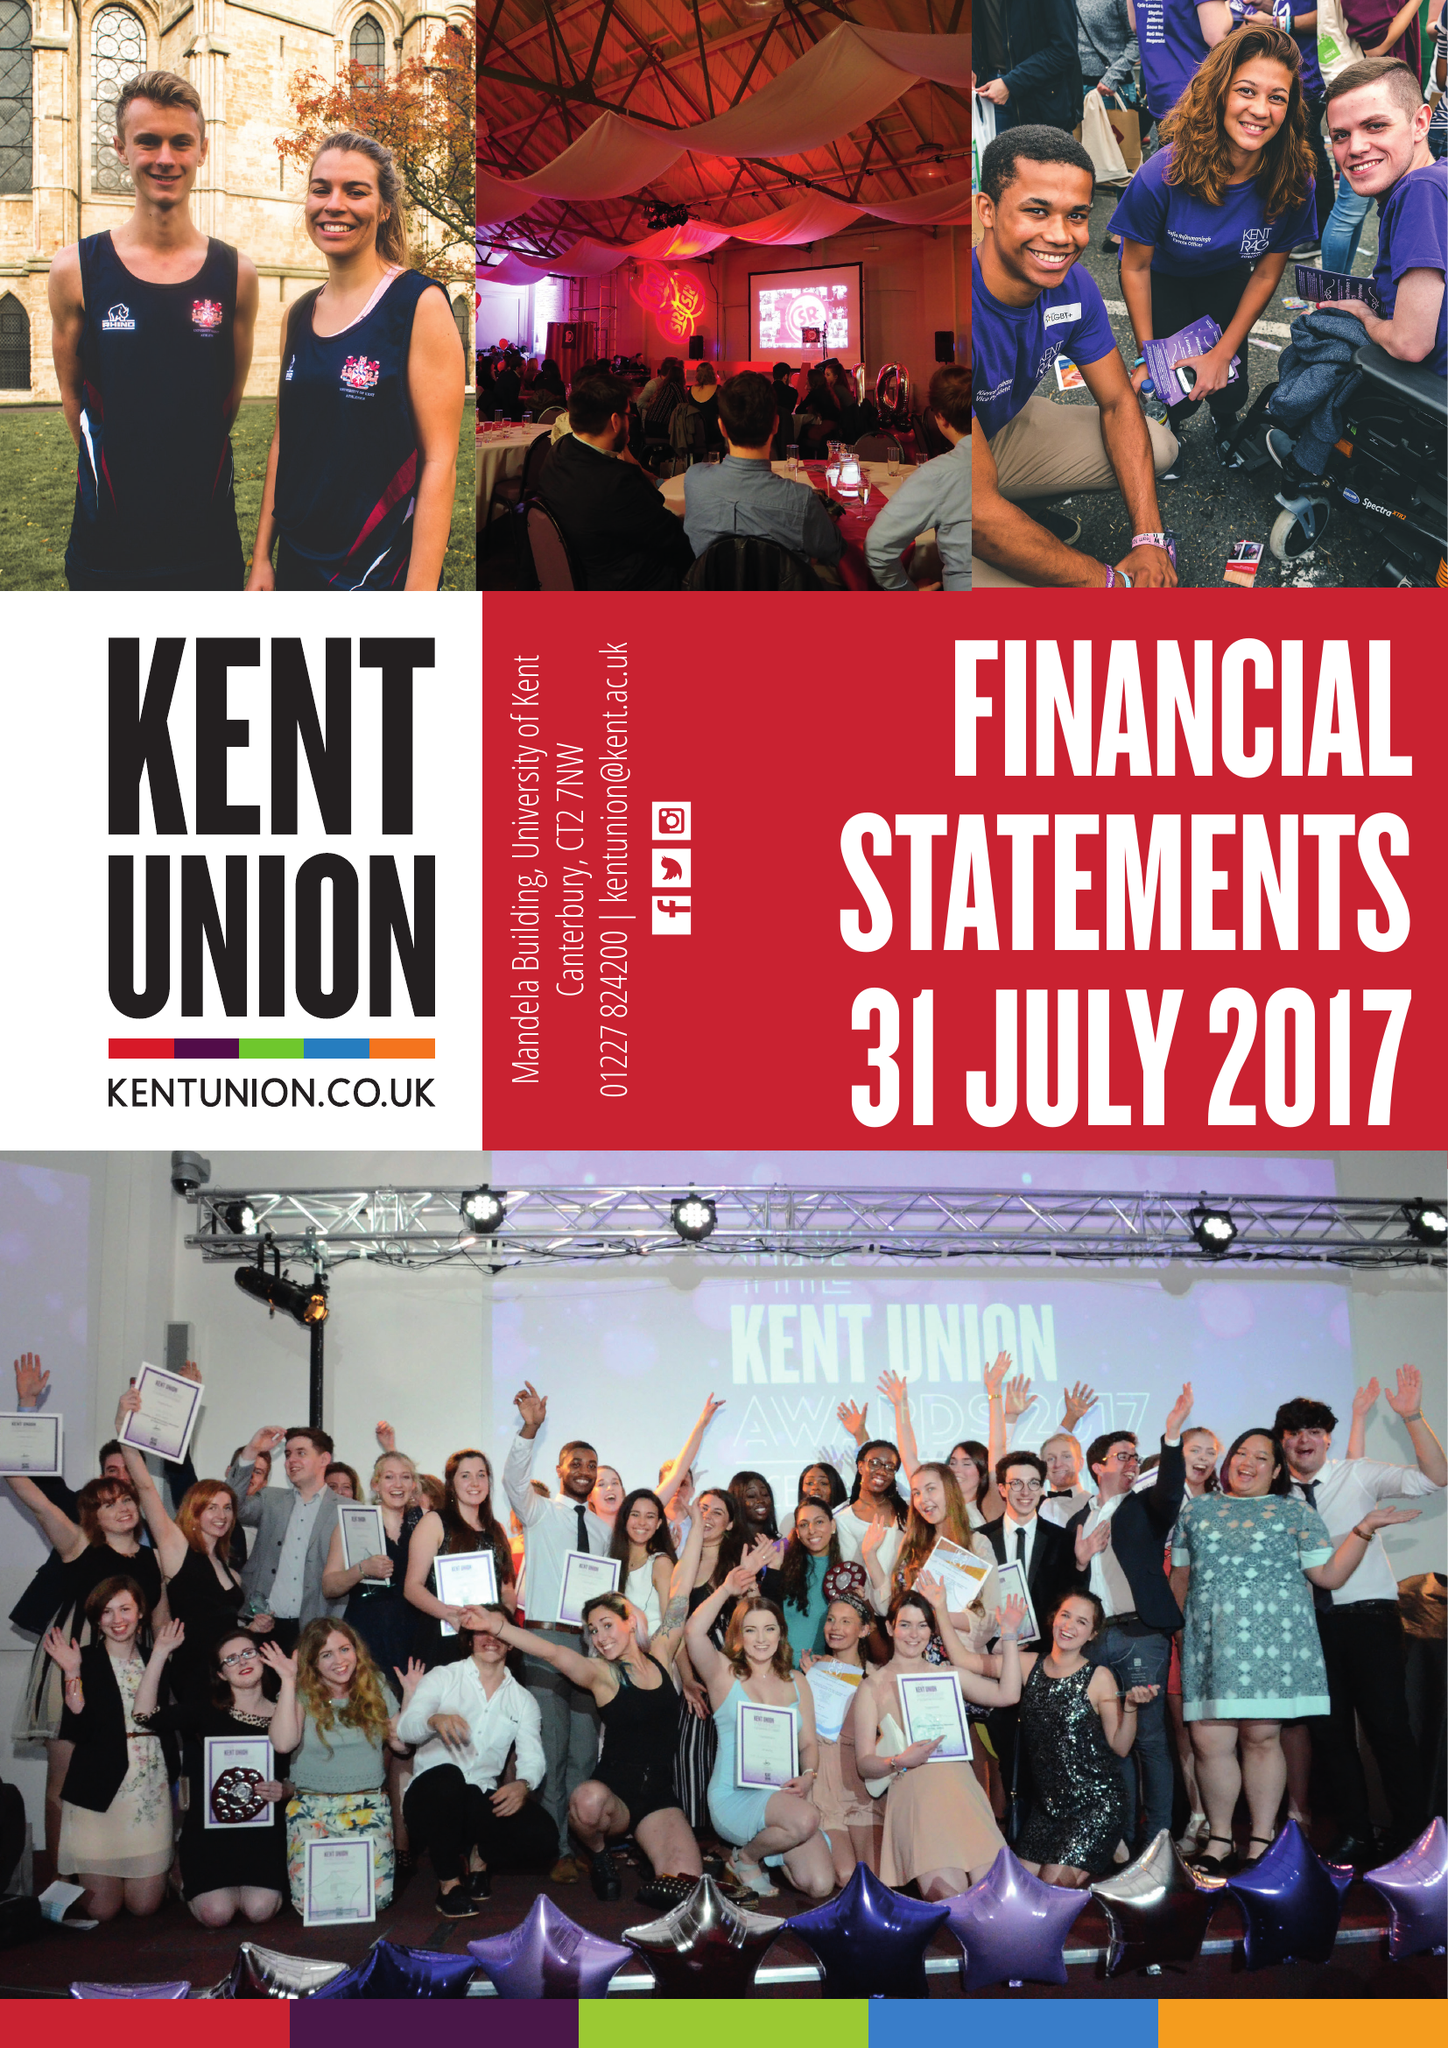What is the value for the spending_annually_in_british_pounds?
Answer the question using a single word or phrase. 11891899.00 